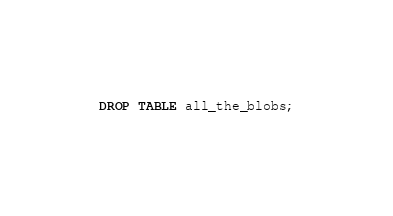<code> <loc_0><loc_0><loc_500><loc_500><_SQL_>DROP TABLE all_the_blobs;
</code> 